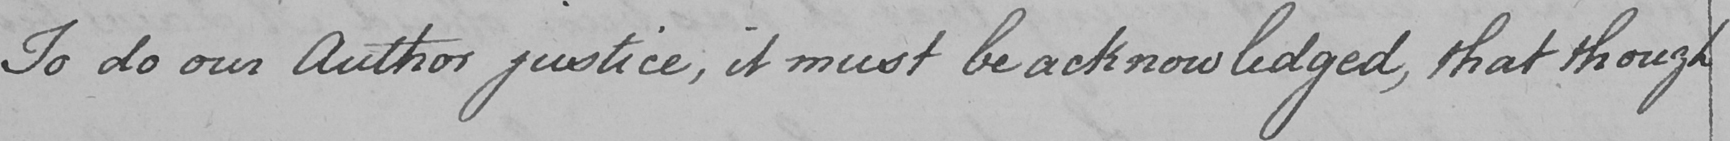Please transcribe the handwritten text in this image. To do our Author justice , it must be acknowledged , that though 